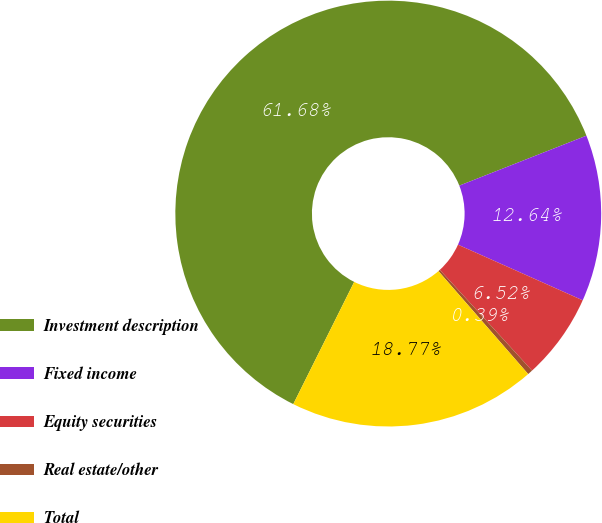Convert chart. <chart><loc_0><loc_0><loc_500><loc_500><pie_chart><fcel>Investment description<fcel>Fixed income<fcel>Equity securities<fcel>Real estate/other<fcel>Total<nl><fcel>61.68%<fcel>12.64%<fcel>6.52%<fcel>0.39%<fcel>18.77%<nl></chart> 